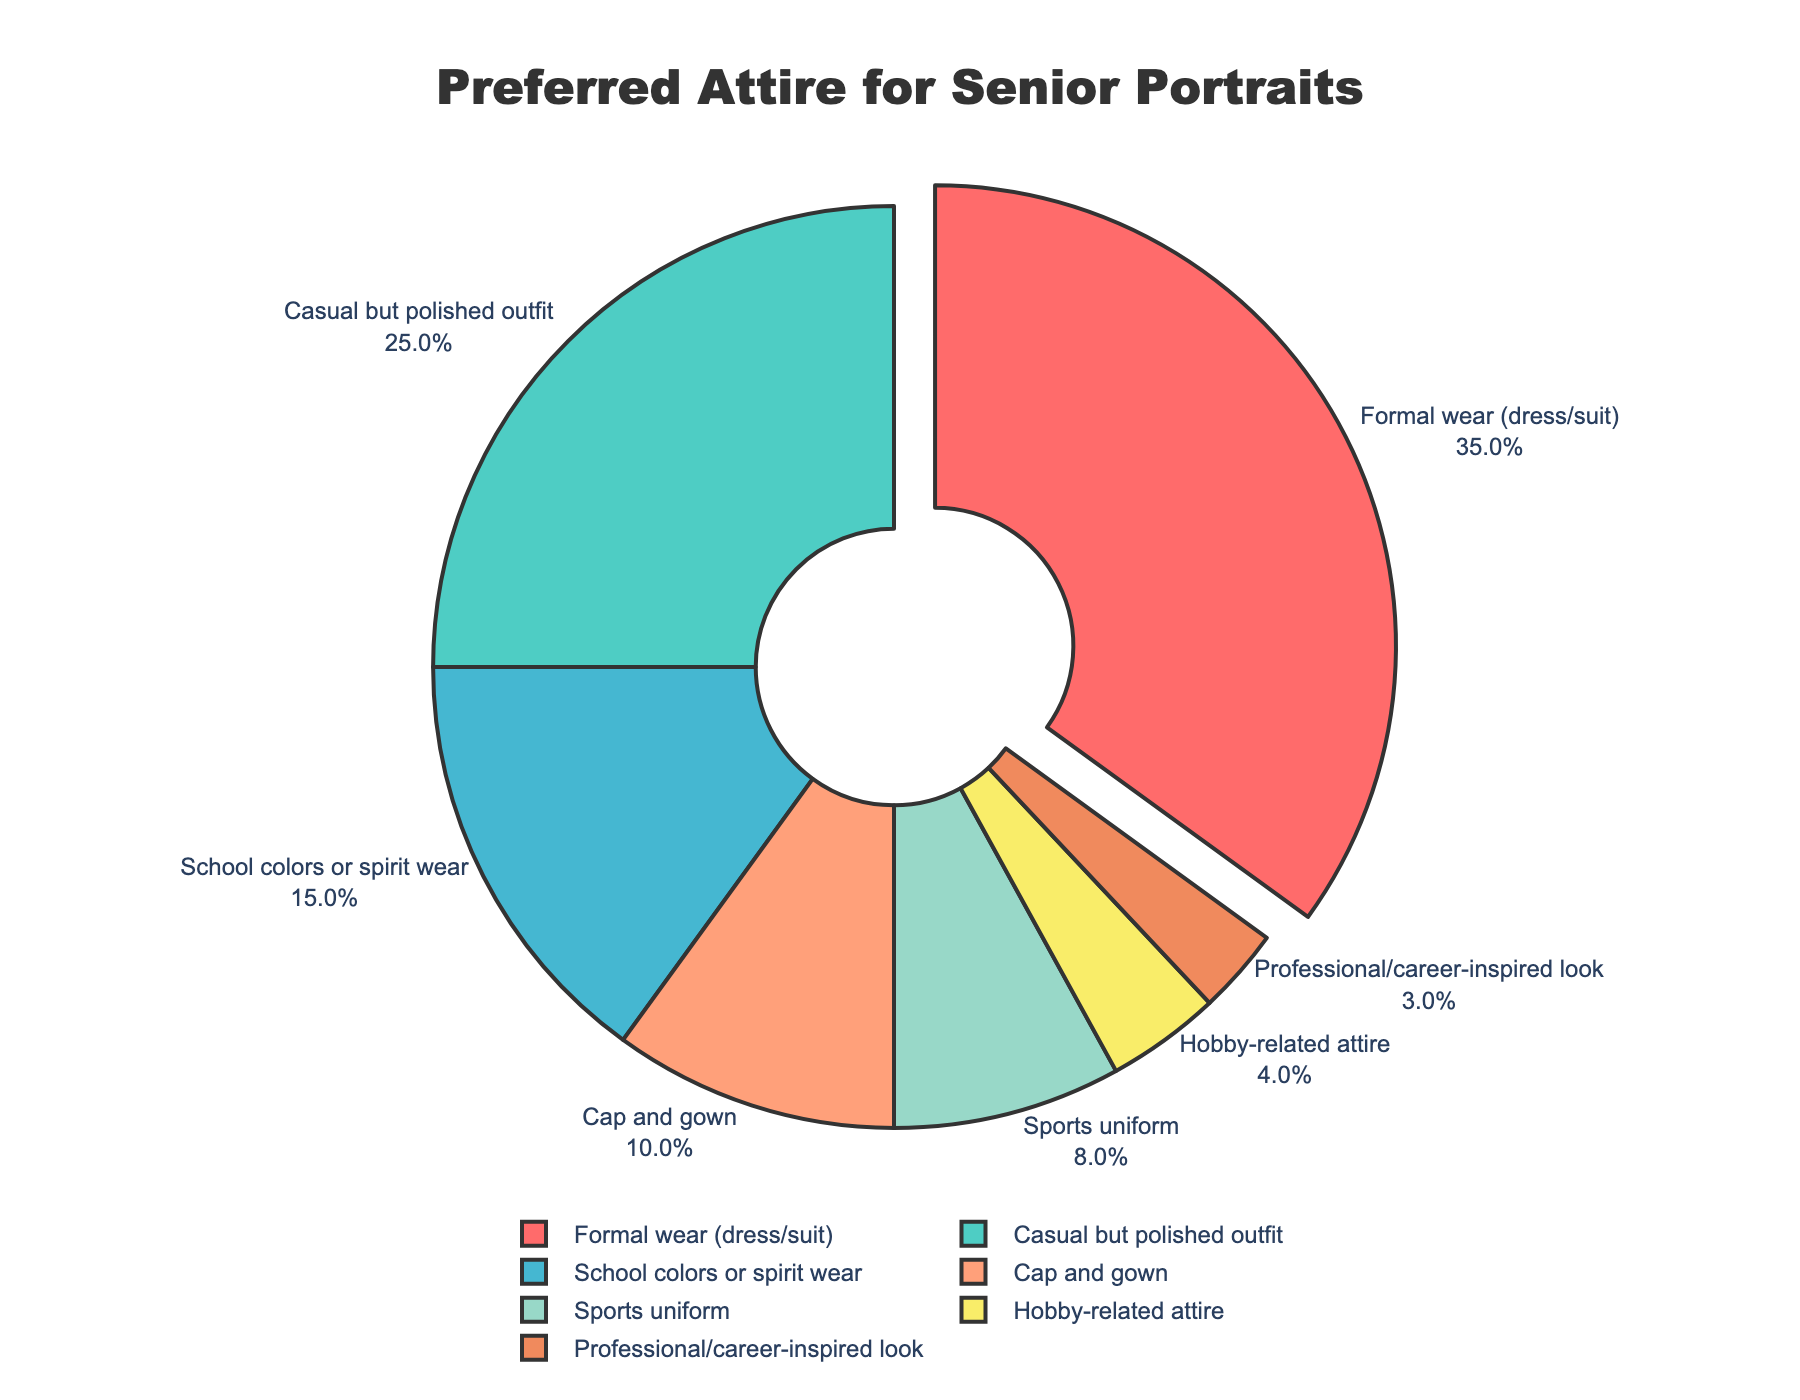What is the most preferred attire choice for senior portraits? The segment with the highest percentage is labeled "Formal wear (dress/suit)" with 35%.
Answer: Formal wear (dress/suit) Which attire categories together make up half of the preferences? Combining the percentages of "Formal wear (dress/suit)" (35%) and "Casual but polished outfit" (25%) gives a total of 60%, which exceeds half. Therefore, these two categories together make up more than half of the preferences.
Answer: Formal wear (dress/suit) and Casual but polished outfit How does the percentage of students choosing a "Sports uniform" compare to those choosing "School colors or spirit wear"? The percentage for "Sports uniform" is 8%, while for "School colors or spirit wear" it is 15%. 15% is greater than 8%.
Answer: School colors or spirit wear is preferred more than Sports uniform What is the total percentage of students choosing either "Cap and gown" or a "Professional/career-inspired look"? Adding the percentages of "Cap and gown" (10%) and "Professional/career-inspired look" (3%) gives 10% + 3% = 13%.
Answer: 13% Are there more students who prefer "Hobby-related attire" or "Sports uniform"? The percentage for "Sports uniform" is 8%, and for "Hobby-related attire" it is 4%. 8% is greater than 4%.
Answer: Sports uniform What is the combined percentage of students who prefer "Cap and gown," "Sports uniform," and "Hobby-related attire"? Adding the percentages of "Cap and gown" (10%), "Sports uniform" (8%), and "Hobby-related attire" (4%) gives 10% + 8% + 4% = 22%.
Answer: 22% Which category has the smallest percentage of preference? The segment with the smallest percentage is labeled "Professional/career-inspired look" with 3%.
Answer: Professional/career-inspired look How much higher is the percentage of "Formal wear (dress/suit)" compared to "Casual but polished outfit"? The percentage for "Formal wear (dress/suit)" is 35%, and for "Casual but polished outfit" it is 25%. The difference is 35% - 25% = 10%.
Answer: 10% Which attire categories have a preference percentage below 10%? The categories "Cap and gown" (10%), "Sports uniform" (8%), "Hobby-related attire" (4%), and "Professional/career-inspired look" (3%) have preference percentages below 10%.
Answer: Sports uniform, Hobby-related attire, Professional/career-inspired look What is the difference in percentage between the highest and the lowest preferred attire choices? The highest percentage is for "Formal wear (dress/suit)" at 35% and the lowest is for "Professional/career-inspired look" at 3%. The difference is 35% - 3% = 32%.
Answer: 32% 